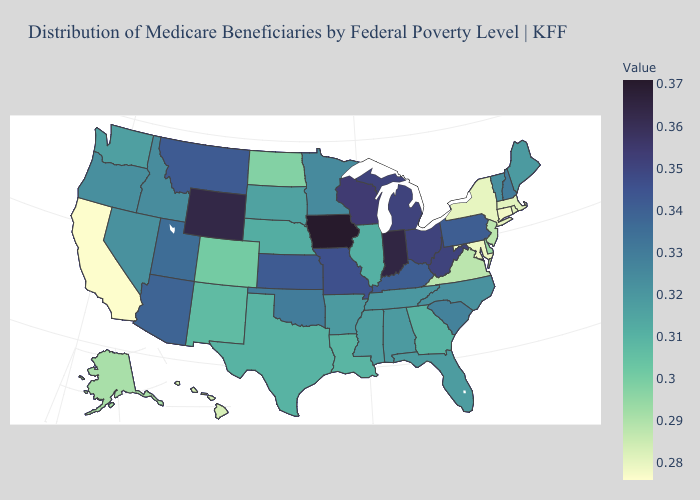Does South Dakota have the highest value in the MidWest?
Write a very short answer. No. Which states have the lowest value in the South?
Give a very brief answer. Maryland. Which states have the highest value in the USA?
Answer briefly. Iowa. Does the map have missing data?
Answer briefly. No. Does the map have missing data?
Give a very brief answer. No. 